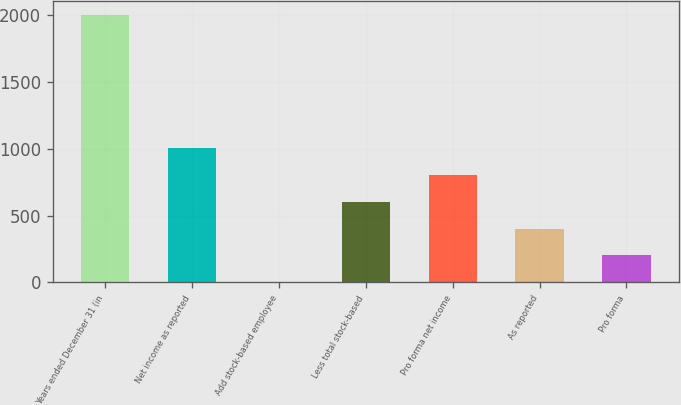<chart> <loc_0><loc_0><loc_500><loc_500><bar_chart><fcel>Years ended December 31 (in<fcel>Net income as reported<fcel>Add stock-based employee<fcel>Less total stock-based<fcel>Pro forma net income<fcel>As reported<fcel>Pro forma<nl><fcel>2004<fcel>1002.7<fcel>1.4<fcel>602.18<fcel>802.44<fcel>401.92<fcel>201.66<nl></chart> 